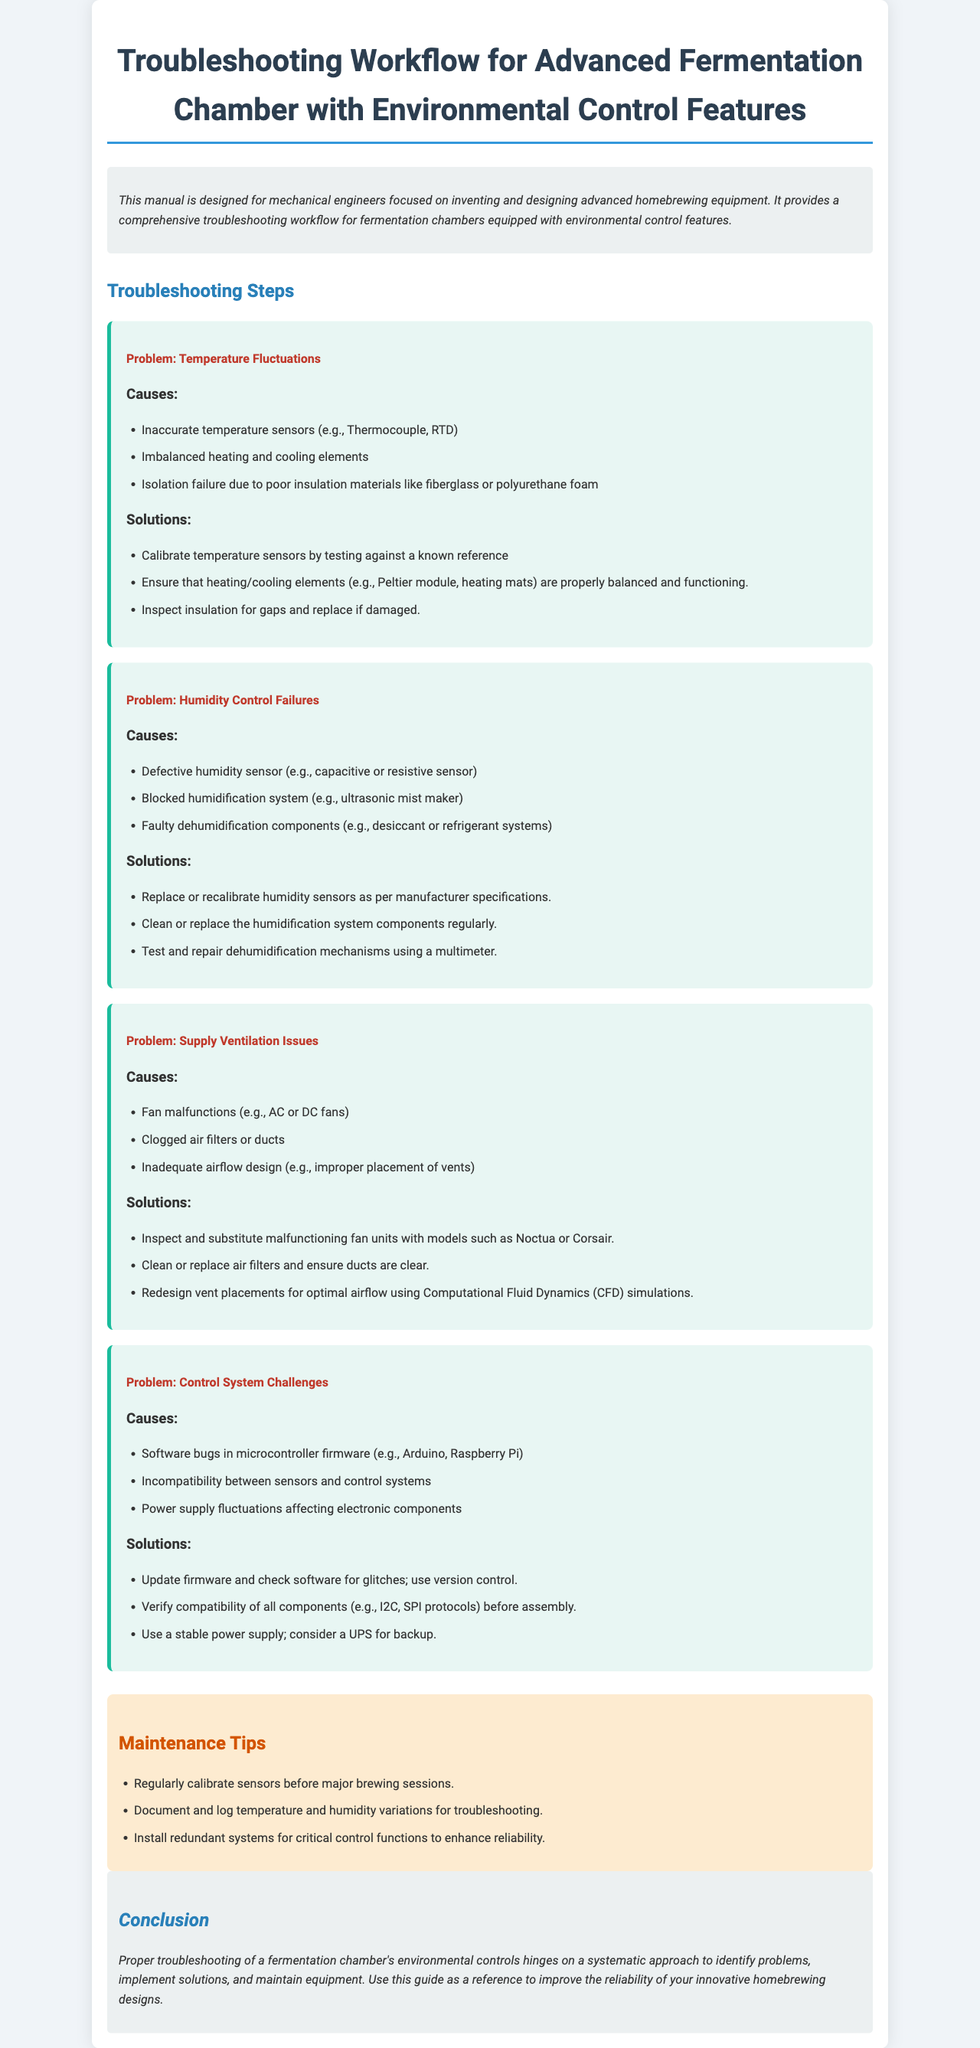What is the main purpose of the manual? The manual is designed for mechanical engineers focused on inventing and designing advanced homebrewing equipment.
Answer: advanced homebrewing equipment What is one cause of temperature fluctuations? The document lists several causes of temperature fluctuations, one of which is inaccurate temperature sensors.
Answer: inaccurate temperature sensors What should be done to address blocked humidification systems? The solution provided for this issue is to clean or replace the humidification system components regularly.
Answer: clean or replace How can fan malfunctions affect supply ventilation? The document mentions that fan malfunctions are one of the causes of supply ventilation issues.
Answer: fan malfunctions What type of failure is addressed under "Humidity Control Failures"? The document discusses a problem related to humidity control failures in the fermentation chamber.
Answer: humidity control failures What maintenance tip is suggested in the manual? One of the maintenance tips is to regularly calibrate sensors before major brewing sessions.
Answer: regularly calibrate sensors What is a suggested solution for software bugs in control systems? The document recommends updating firmware and checking software for glitches as a solution.
Answer: update firmware Which electronic components might be affected by power supply fluctuations? The document addresses power supply fluctuations affecting electronic components in control systems.
Answer: electronic components What type of approaches does the conclusion emphasize for troubleshooting? The conclusion states a systematic approach to identify problems, implement solutions, and maintain equipment is essential.
Answer: systematic approach 